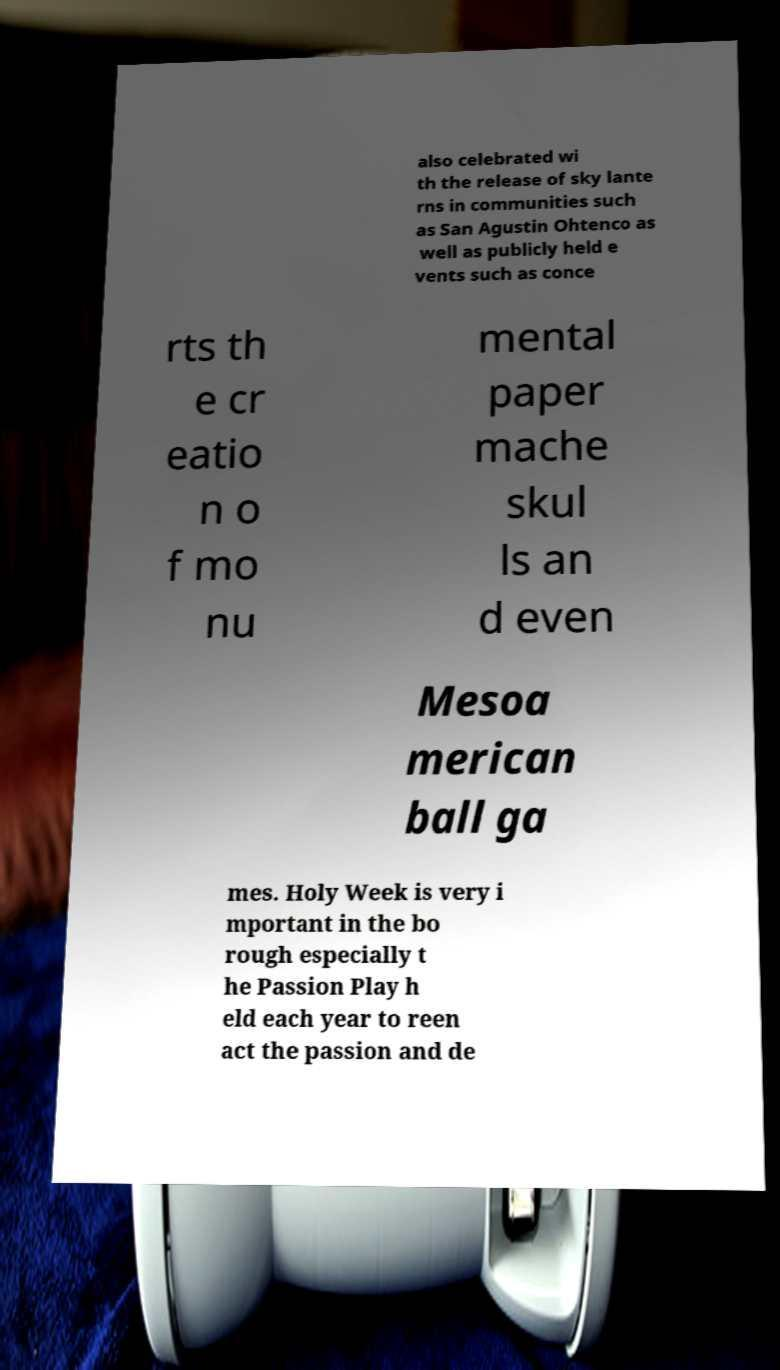Could you assist in decoding the text presented in this image and type it out clearly? also celebrated wi th the release of sky lante rns in communities such as San Agustin Ohtenco as well as publicly held e vents such as conce rts th e cr eatio n o f mo nu mental paper mache skul ls an d even Mesoa merican ball ga mes. Holy Week is very i mportant in the bo rough especially t he Passion Play h eld each year to reen act the passion and de 